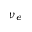<formula> <loc_0><loc_0><loc_500><loc_500>\nu _ { e }</formula> 